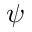<formula> <loc_0><loc_0><loc_500><loc_500>\psi</formula> 